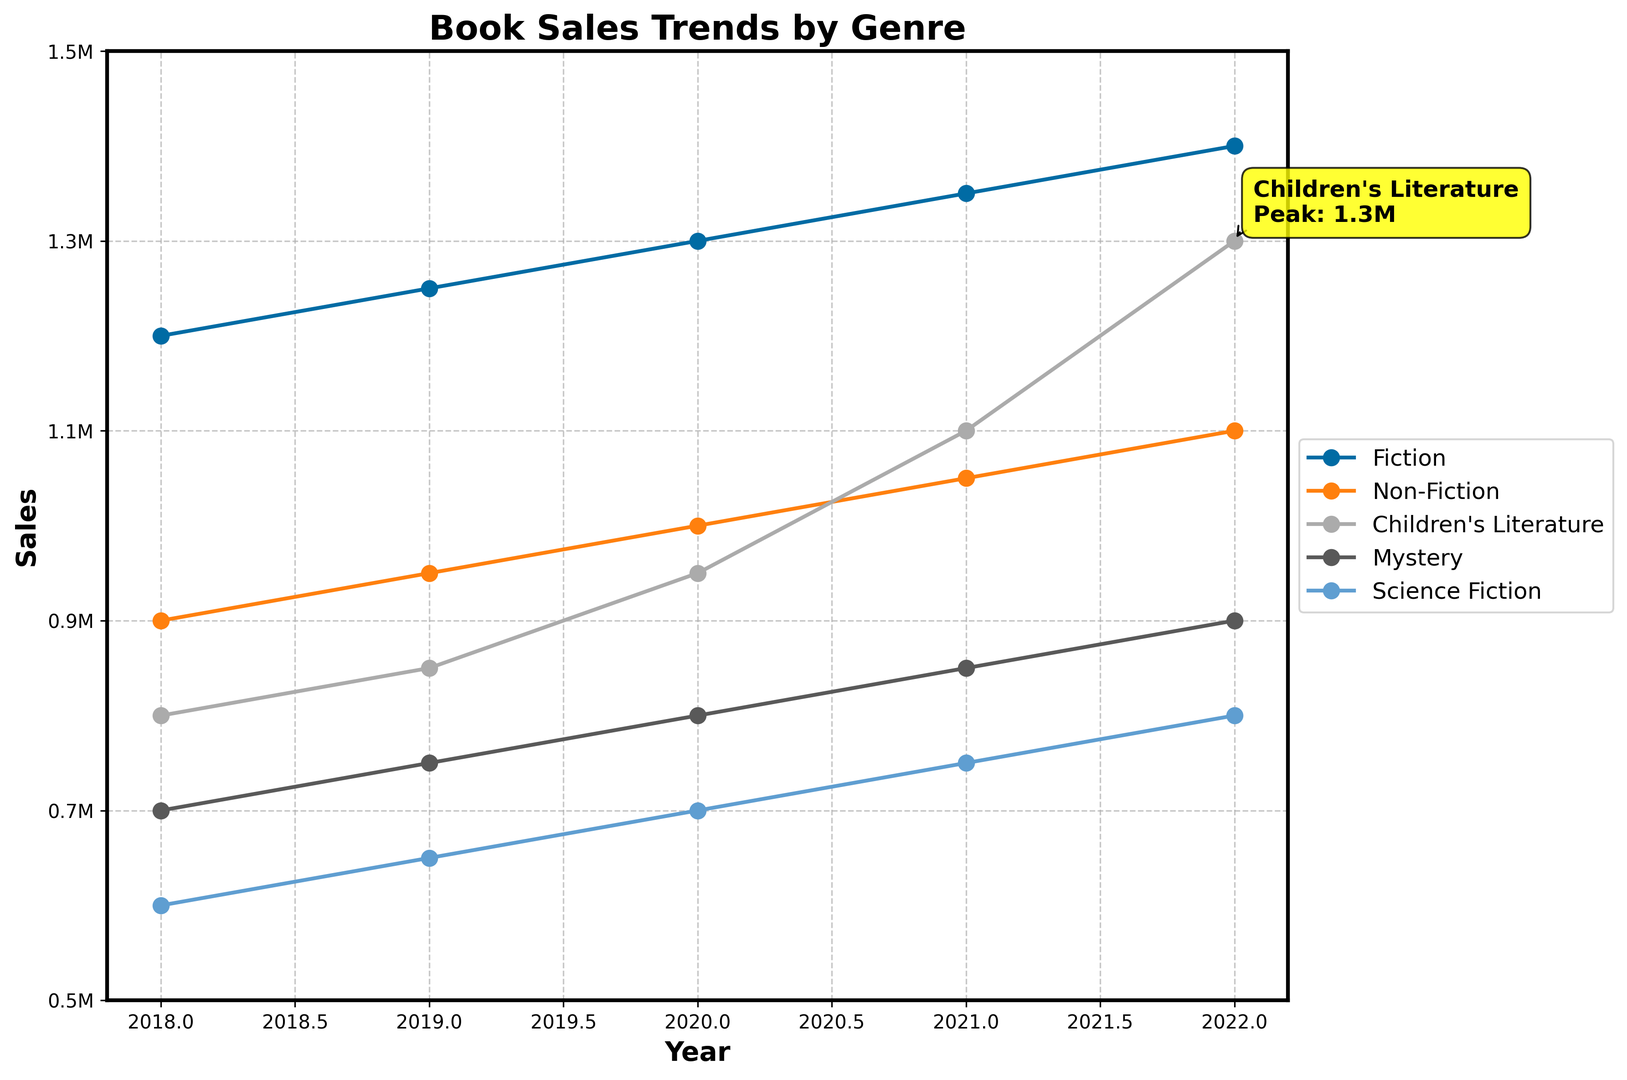What is the general trend observed in Fiction book sales from 2018 to 2022? To answer this question, we look at the Fiction line on the plot. The sales numbers are increasing every year: 1.2M in 2018, 1.25M in 2019, 1.3M in 2020, 1.35M in 2021, and 1.4M in 2022. Thus, the general trend is upward.
Answer: An increasing trend Which genre had the peak sales in 2022? To determine the peak sales in 2022, examine the rightmost points on the plot corresponding to the year 2022. Children's Literature has the highest point with 1.3M sales.
Answer: Children's Literature How much did Non-Fiction sales increase from 2018 to 2022? We look at the Non-Fiction line starting from 900,000 in 2018 to 1,100,000 in 2022. The increase is calculated as 1,100,000 - 900,000.
Answer: 200,000 What year did Children's Literature see a significant jump in sales, and by how much did it increase? Examine the plot for Children's Literature. There is a noticeable increase between 2020 and 2021, where sales went from 950,000 to 1,100,000. The increase is 1,100,000 - 950,000.
Answer: 2021, 150,000 Compare the sales growth of Mystery and Science Fiction from 2018 to 2022. Which one had a higher growth rate? For Mystery, sales grew from 700,000 to 900,000, an increase of 200,000. For Science Fiction, sales grew from 600,000 to 800,000, an increase of 200,000. Since both genres increased by the same amount, their growth rates are equal.
Answer: They had equal growth rates In which year did Fiction sales first surpass 1,300,000? Locate the point at which the Fiction line crosses the 1,300,000 sales mark. It first does so in 2020.
Answer: 2020 What is highlighted about Children's Literature in the plot? There is an annotation indicating the peak sales of Children's Literature with a note showing its peak being 1.3M.
Answer: Peak: 1.3M Which genre had the lowest sales in 2018? Look at the leftmost points of all the lines in the plot. Science Fiction has the lowest sales at 600,000.
Answer: Science Fiction 